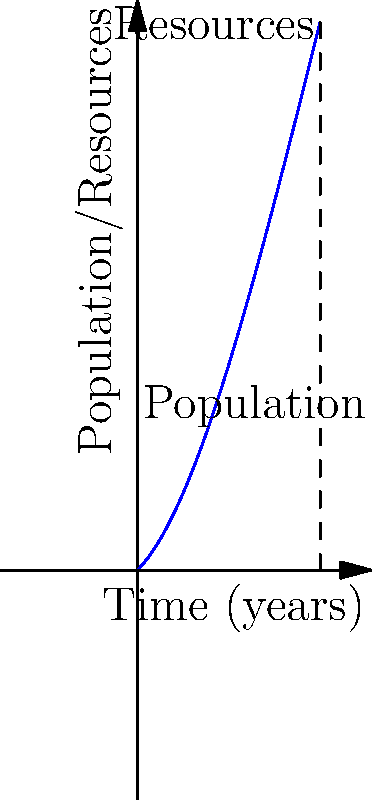In a medieval fantasy setting, the relationship between population growth and resource depletion is represented by the polynomial function $f(x) = -0.01x^3 + 0.3x^2 + x$, where $x$ represents time in years and $f(x)$ represents the population size relative to available resources. After how many years does the population reach its peak, and what implications might this have for the fantasy world's stability? To solve this problem, we need to follow these steps:

1) The population reaches its peak when the rate of change (derivative) of the function is zero. Let's find the derivative:

   $f'(x) = -0.03x^2 + 0.6x + 1$

2) Set the derivative to zero and solve for x:

   $-0.03x^2 + 0.6x + 1 = 0$

3) This is a quadratic equation. We can solve it using the quadratic formula:

   $x = \frac{-b \pm \sqrt{b^2 - 4ac}}{2a}$

   Where $a = -0.03$, $b = 0.6$, and $c = 1$

4) Plugging in these values:

   $x = \frac{-0.6 \pm \sqrt{0.6^2 - 4(-0.03)(1)}}{2(-0.03)}$

5) Simplifying:

   $x = \frac{-0.6 \pm \sqrt{0.36 + 0.12}}{-0.06} = \frac{-0.6 \pm \sqrt{0.48}}{-0.06} = \frac{-0.6 \pm 0.6928}{-0.06}$

6) This gives us two solutions:

   $x_1 = \frac{-0.6 + 0.6928}{-0.06} \approx -1.55$ (which we can discard as it's negative)
   $x_2 = \frac{-0.6 - 0.6928}{-0.06} \approx 21.55$

7) Therefore, the population reaches its peak after approximately 21.55 years.

Implications for the fantasy world's stability:

1) Rapid growth: The population grows rapidly in the first 21.55 years, which could lead to expansion and prosperity.

2) Resource strain: As the population approaches its peak, resources may become strained, potentially leading to conflicts.

3) Decline: After the peak, the population starts to decline relative to resources, which could indicate a period of societal stress or collapse.

4) Cyclical nature: This model suggests a cyclical nature of civilizations, which could be incorporated into the fantasy world's history and lore.

5) Technological or magical intervention: The writer might introduce elements that alter this curve, such as new technologies or magical solutions to resource scarcity.
Answer: 21.55 years; potential for initial prosperity followed by resource strain and societal stress. 